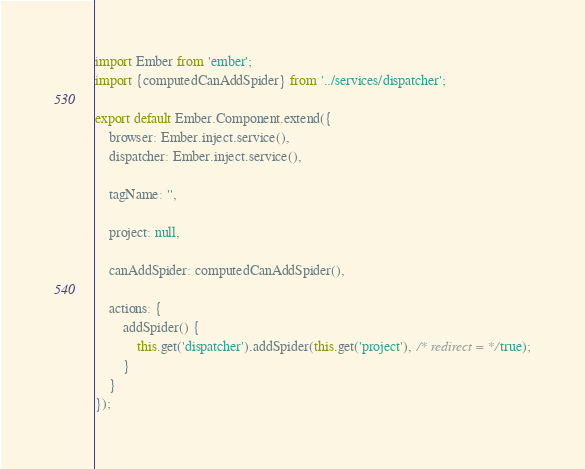Convert code to text. <code><loc_0><loc_0><loc_500><loc_500><_JavaScript_>import Ember from 'ember';
import {computedCanAddSpider} from '../services/dispatcher';

export default Ember.Component.extend({
    browser: Ember.inject.service(),
    dispatcher: Ember.inject.service(),

    tagName: '',

    project: null,

    canAddSpider: computedCanAddSpider(),

    actions: {
        addSpider() {
            this.get('dispatcher').addSpider(this.get('project'), /* redirect = */true);
        }
    }
});
</code> 